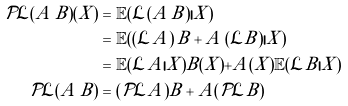Convert formula to latex. <formula><loc_0><loc_0><loc_500><loc_500>\mathcal { P } \mathcal { L } ( A \, B ) ( X ) & = \mathbb { E } ( \mathcal { L } ( A \, B ) | X ) \\ & = \mathbb { E } ( ( \mathcal { L } A ) \, B + A \, ( \mathcal { L } B ) | X ) \\ & = \mathbb { E } ( \mathcal { L } A | X ) B ( X ) + A ( X ) \mathbb { E } ( \mathcal { L } B | X ) \\ \mathcal { P } \mathcal { L } ( A \, B ) & = ( \mathcal { P } \mathcal { L } A ) B + A ( \mathcal { P } \mathcal { L } B )</formula> 